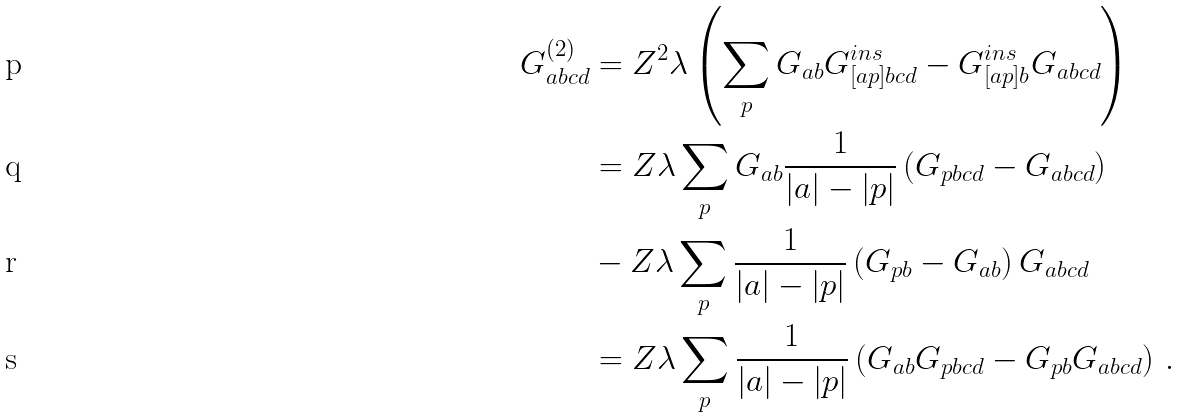Convert formula to latex. <formula><loc_0><loc_0><loc_500><loc_500>G ^ { ( 2 ) } _ { a b c d } & = Z ^ { 2 } \lambda \left ( \sum _ { p } G _ { a b } G ^ { i n s } _ { [ a p ] b c d } - G ^ { i n s } _ { [ a p ] b } G _ { a b c d } \right ) \\ & = Z \lambda \sum _ { p } G _ { a b } \frac { 1 } { | a | - | p | } \left ( G _ { p b c d } - G _ { a b c d } \right ) \\ & - Z \lambda \sum _ { p } \frac { 1 } { | a | - | p | } \left ( G _ { p b } - G _ { a b } \right ) G _ { a b c d } \\ & = Z \lambda \sum _ { p } \frac { 1 } { | a | - | p | } \left ( G _ { a b } G _ { p b c d } - G _ { p b } G _ { a b c d } \right ) \, .</formula> 